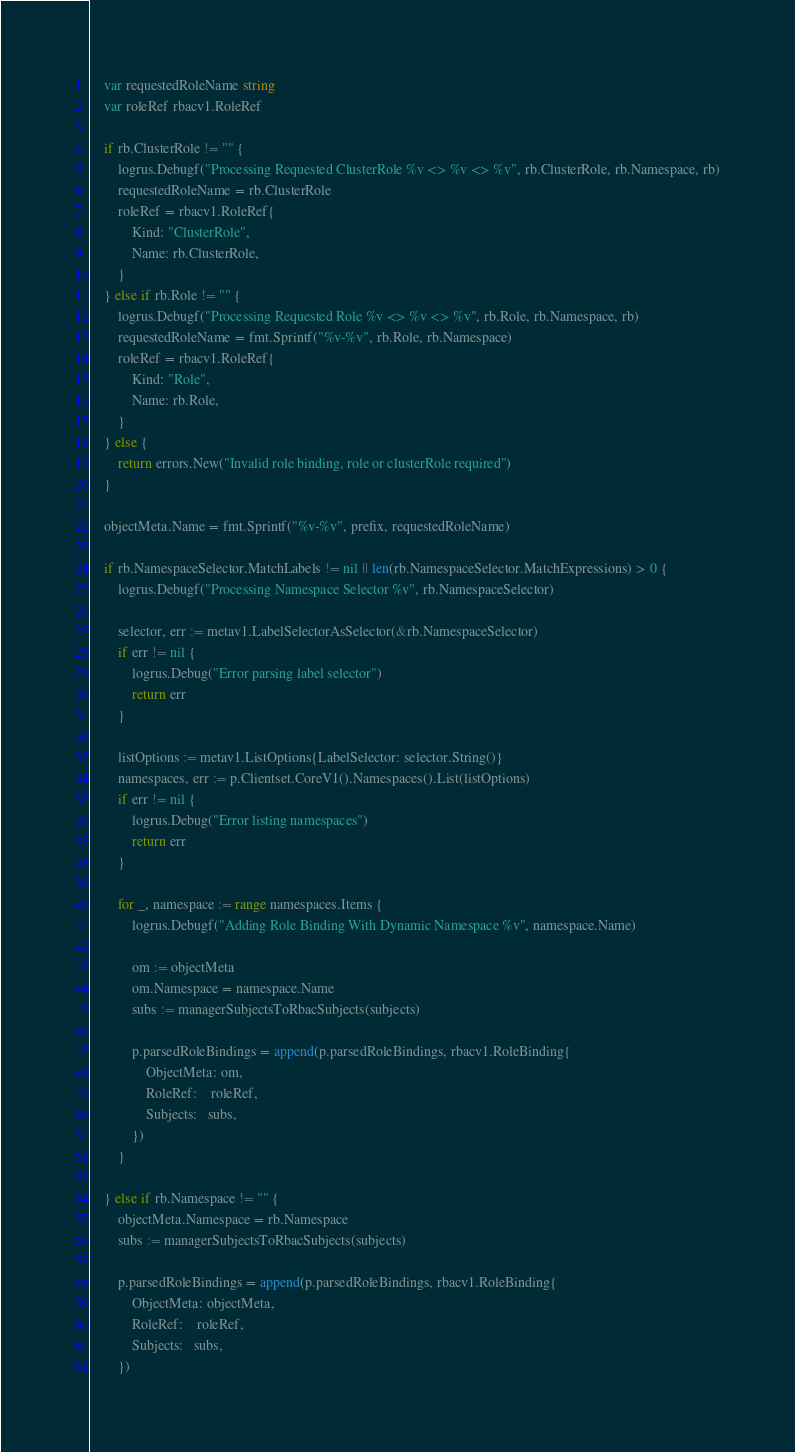<code> <loc_0><loc_0><loc_500><loc_500><_Go_>
	var requestedRoleName string
	var roleRef rbacv1.RoleRef

	if rb.ClusterRole != "" {
		logrus.Debugf("Processing Requested ClusterRole %v <> %v <> %v", rb.ClusterRole, rb.Namespace, rb)
		requestedRoleName = rb.ClusterRole
		roleRef = rbacv1.RoleRef{
			Kind: "ClusterRole",
			Name: rb.ClusterRole,
		}
	} else if rb.Role != "" {
		logrus.Debugf("Processing Requested Role %v <> %v <> %v", rb.Role, rb.Namespace, rb)
		requestedRoleName = fmt.Sprintf("%v-%v", rb.Role, rb.Namespace)
		roleRef = rbacv1.RoleRef{
			Kind: "Role",
			Name: rb.Role,
		}
	} else {
		return errors.New("Invalid role binding, role or clusterRole required")
	}

	objectMeta.Name = fmt.Sprintf("%v-%v", prefix, requestedRoleName)

	if rb.NamespaceSelector.MatchLabels != nil || len(rb.NamespaceSelector.MatchExpressions) > 0 {
		logrus.Debugf("Processing Namespace Selector %v", rb.NamespaceSelector)

		selector, err := metav1.LabelSelectorAsSelector(&rb.NamespaceSelector)
		if err != nil {
			logrus.Debug("Error parsing label selector")
			return err
		}

		listOptions := metav1.ListOptions{LabelSelector: selector.String()}
		namespaces, err := p.Clientset.CoreV1().Namespaces().List(listOptions)
		if err != nil {
			logrus.Debug("Error listing namespaces")
			return err
		}

		for _, namespace := range namespaces.Items {
			logrus.Debugf("Adding Role Binding With Dynamic Namespace %v", namespace.Name)

			om := objectMeta
			om.Namespace = namespace.Name
			subs := managerSubjectsToRbacSubjects(subjects)

			p.parsedRoleBindings = append(p.parsedRoleBindings, rbacv1.RoleBinding{
				ObjectMeta: om,
				RoleRef:    roleRef,
				Subjects:   subs,
			})
		}

	} else if rb.Namespace != "" {
		objectMeta.Namespace = rb.Namespace
		subs := managerSubjectsToRbacSubjects(subjects)

		p.parsedRoleBindings = append(p.parsedRoleBindings, rbacv1.RoleBinding{
			ObjectMeta: objectMeta,
			RoleRef:    roleRef,
			Subjects:   subs,
		})
</code> 